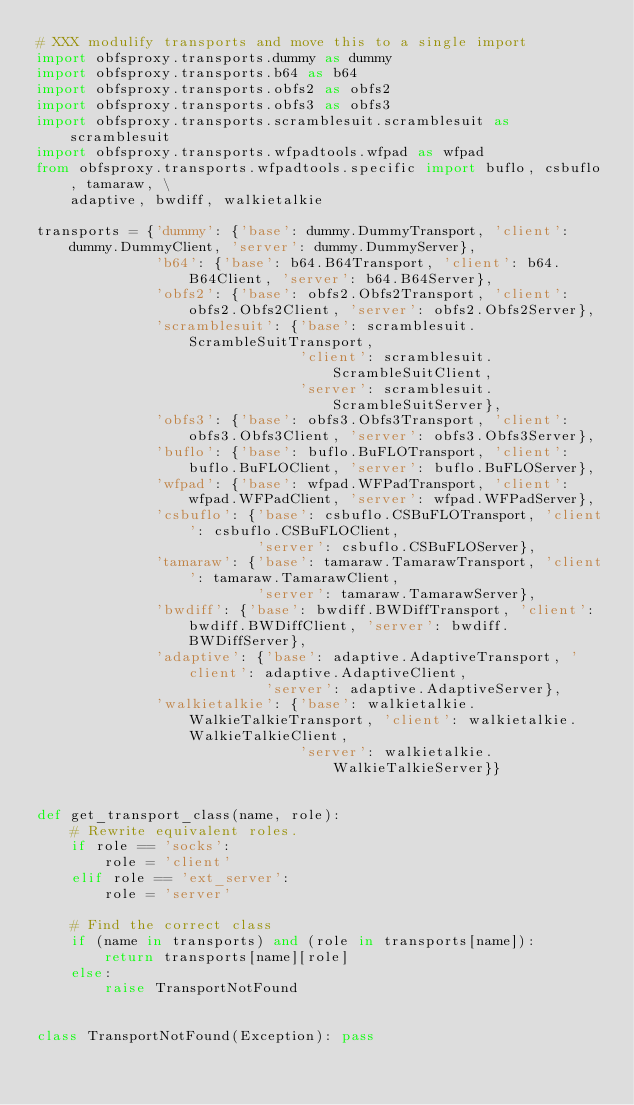<code> <loc_0><loc_0><loc_500><loc_500><_Python_># XXX modulify transports and move this to a single import
import obfsproxy.transports.dummy as dummy
import obfsproxy.transports.b64 as b64
import obfsproxy.transports.obfs2 as obfs2
import obfsproxy.transports.obfs3 as obfs3
import obfsproxy.transports.scramblesuit.scramblesuit as scramblesuit
import obfsproxy.transports.wfpadtools.wfpad as wfpad
from obfsproxy.transports.wfpadtools.specific import buflo, csbuflo, tamaraw, \
    adaptive, bwdiff, walkietalkie

transports = {'dummy': {'base': dummy.DummyTransport, 'client': dummy.DummyClient, 'server': dummy.DummyServer},
              'b64': {'base': b64.B64Transport, 'client': b64.B64Client, 'server': b64.B64Server},
              'obfs2': {'base': obfs2.Obfs2Transport, 'client': obfs2.Obfs2Client, 'server': obfs2.Obfs2Server},
              'scramblesuit': {'base': scramblesuit.ScrambleSuitTransport,
                               'client': scramblesuit.ScrambleSuitClient,
                               'server': scramblesuit.ScrambleSuitServer},
              'obfs3': {'base': obfs3.Obfs3Transport, 'client': obfs3.Obfs3Client, 'server': obfs3.Obfs3Server},
              'buflo': {'base': buflo.BuFLOTransport, 'client': buflo.BuFLOClient, 'server': buflo.BuFLOServer},
              'wfpad': {'base': wfpad.WFPadTransport, 'client': wfpad.WFPadClient, 'server': wfpad.WFPadServer},
              'csbuflo': {'base': csbuflo.CSBuFLOTransport, 'client': csbuflo.CSBuFLOClient,
                          'server': csbuflo.CSBuFLOServer},
              'tamaraw': {'base': tamaraw.TamarawTransport, 'client': tamaraw.TamarawClient,
                          'server': tamaraw.TamarawServer},
              'bwdiff': {'base': bwdiff.BWDiffTransport, 'client': bwdiff.BWDiffClient, 'server': bwdiff.BWDiffServer},
              'adaptive': {'base': adaptive.AdaptiveTransport, 'client': adaptive.AdaptiveClient,
                           'server': adaptive.AdaptiveServer},
              'walkietalkie': {'base': walkietalkie.WalkieTalkieTransport, 'client': walkietalkie.WalkieTalkieClient,
                               'server': walkietalkie.WalkieTalkieServer}}


def get_transport_class(name, role):
    # Rewrite equivalent roles.
    if role == 'socks':
        role = 'client'
    elif role == 'ext_server':
        role = 'server'

    # Find the correct class
    if (name in transports) and (role in transports[name]):
        return transports[name][role]
    else:
        raise TransportNotFound


class TransportNotFound(Exception): pass
</code> 